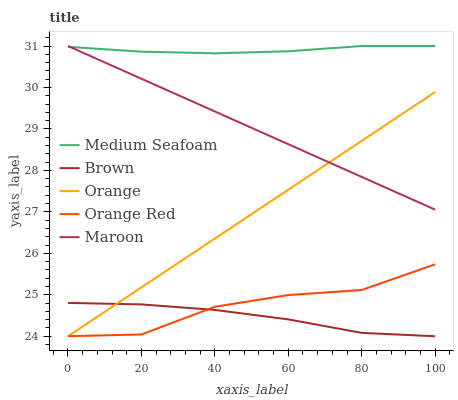Does Brown have the minimum area under the curve?
Answer yes or no. Yes. Does Medium Seafoam have the maximum area under the curve?
Answer yes or no. Yes. Does Medium Seafoam have the minimum area under the curve?
Answer yes or no. No. Does Brown have the maximum area under the curve?
Answer yes or no. No. Is Orange the smoothest?
Answer yes or no. Yes. Is Orange Red the roughest?
Answer yes or no. Yes. Is Brown the smoothest?
Answer yes or no. No. Is Brown the roughest?
Answer yes or no. No. Does Orange have the lowest value?
Answer yes or no. Yes. Does Medium Seafoam have the lowest value?
Answer yes or no. No. Does Maroon have the highest value?
Answer yes or no. Yes. Does Brown have the highest value?
Answer yes or no. No. Is Brown less than Medium Seafoam?
Answer yes or no. Yes. Is Medium Seafoam greater than Orange Red?
Answer yes or no. Yes. Does Brown intersect Orange?
Answer yes or no. Yes. Is Brown less than Orange?
Answer yes or no. No. Is Brown greater than Orange?
Answer yes or no. No. Does Brown intersect Medium Seafoam?
Answer yes or no. No. 